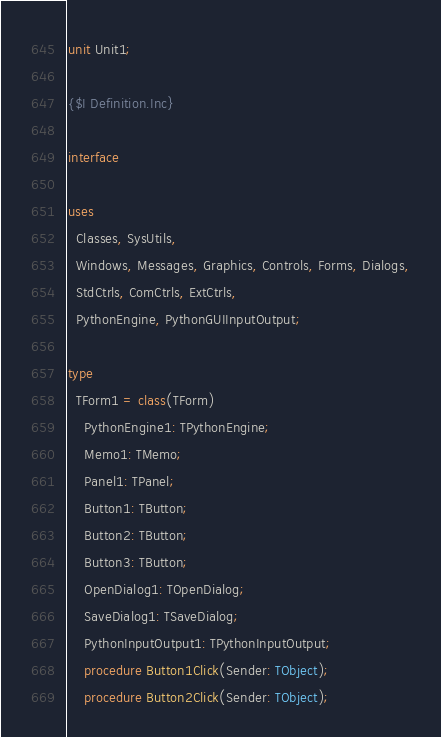<code> <loc_0><loc_0><loc_500><loc_500><_Pascal_>unit Unit1;

{$I Definition.Inc}

interface

uses
  Classes, SysUtils,
  Windows, Messages, Graphics, Controls, Forms, Dialogs,
  StdCtrls, ComCtrls, ExtCtrls,
  PythonEngine, PythonGUIInputOutput;

type
  TForm1 = class(TForm)
    PythonEngine1: TPythonEngine;
    Memo1: TMemo;
    Panel1: TPanel;
    Button1: TButton;
    Button2: TButton;
    Button3: TButton;
    OpenDialog1: TOpenDialog;
    SaveDialog1: TSaveDialog;
    PythonInputOutput1: TPythonInputOutput;
    procedure Button1Click(Sender: TObject);
    procedure Button2Click(Sender: TObject);</code> 